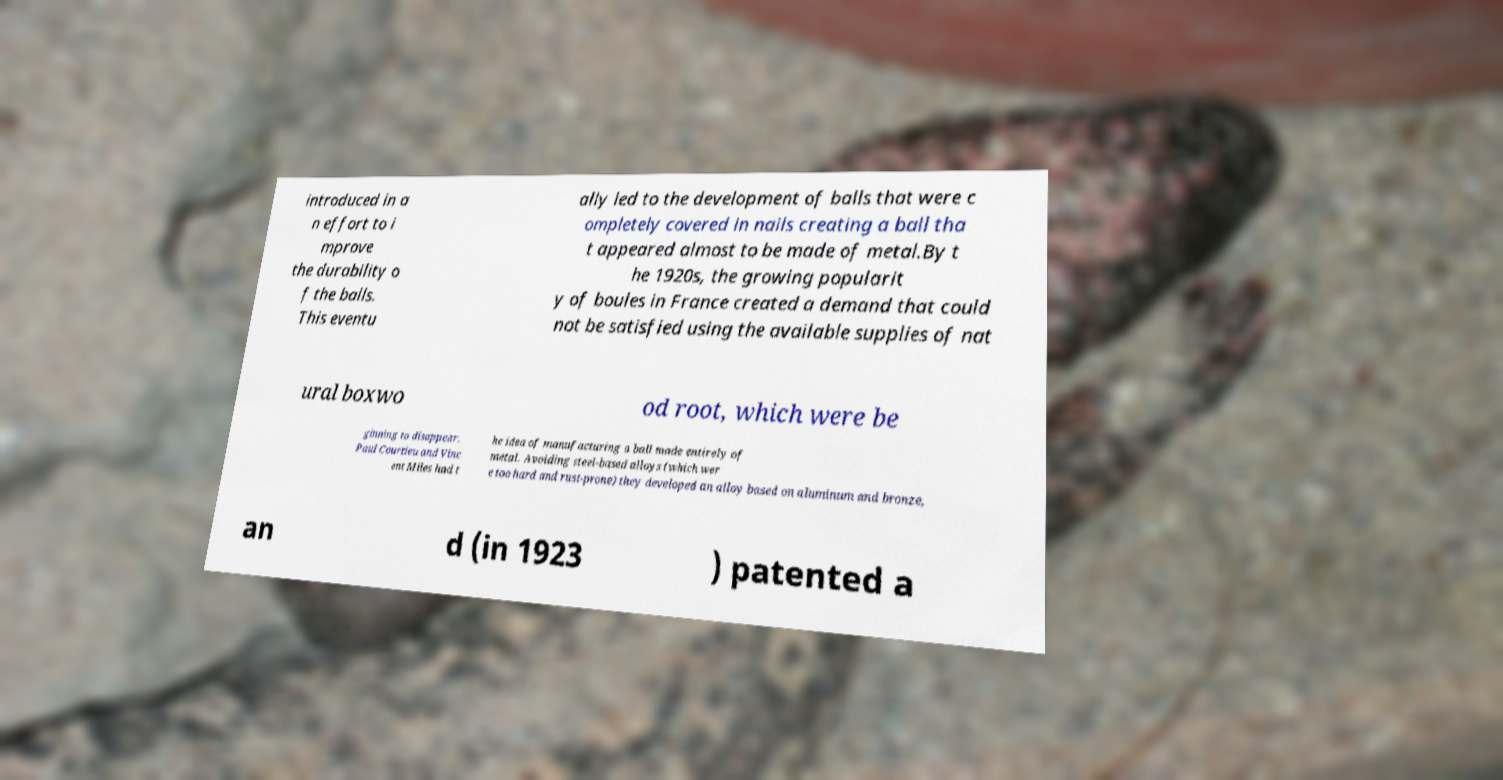Could you assist in decoding the text presented in this image and type it out clearly? introduced in a n effort to i mprove the durability o f the balls. This eventu ally led to the development of balls that were c ompletely covered in nails creating a ball tha t appeared almost to be made of metal.By t he 1920s, the growing popularit y of boules in France created a demand that could not be satisfied using the available supplies of nat ural boxwo od root, which were be ginning to disappear. Paul Courtieu and Vinc ent Miles had t he idea of manufacturing a ball made entirely of metal. Avoiding steel-based alloys (which wer e too hard and rust-prone) they developed an alloy based on aluminum and bronze, an d (in 1923 ) patented a 